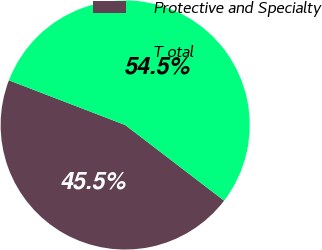<chart> <loc_0><loc_0><loc_500><loc_500><pie_chart><fcel>Protective and Specialty<fcel>T otal<nl><fcel>45.45%<fcel>54.55%<nl></chart> 